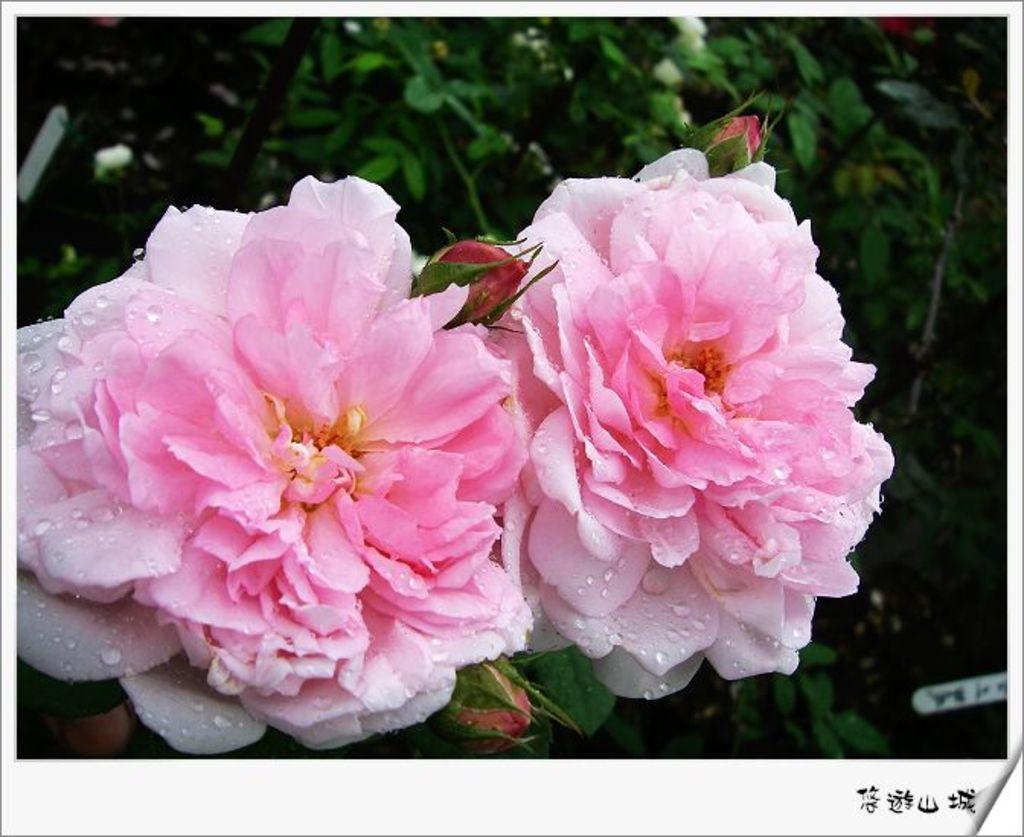How many flowers are in the image? There are two flowers in the image. What are the colors of the flowers? One flower is white in color, and the other is pale pink in color. Can you describe the stage of the flowers in the image? There are bud flowers in the image. What else can be seen in the image besides the flowers? There are leaves in the image. What type of breakfast is being prepared in the image? There is no breakfast or any indication of food preparation in the image; it features two flowers and leaves. 